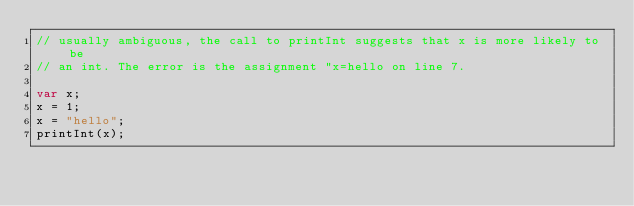<code> <loc_0><loc_0><loc_500><loc_500><_JavaScript_>// usually ambiguous, the call to printInt suggests that x is more likely to be
// an int. The error is the assignment "x=hello on line 7.

var x;
x = 1;
x = "hello";
printInt(x);
</code> 